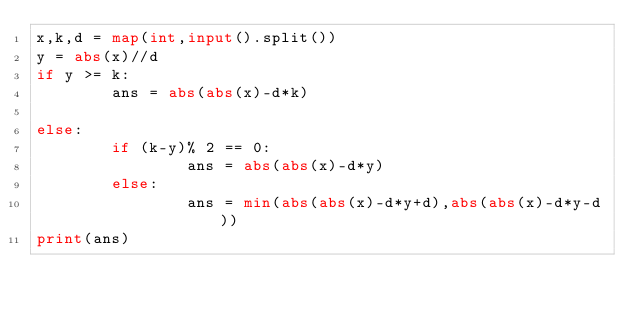Convert code to text. <code><loc_0><loc_0><loc_500><loc_500><_Python_>x,k,d = map(int,input().split())
y = abs(x)//d
if y >= k:
        ans = abs(abs(x)-d*k)

else:
        if (k-y)% 2 == 0:
                ans = abs(abs(x)-d*y)
        else:
                ans = min(abs(abs(x)-d*y+d),abs(abs(x)-d*y-d))
print(ans)</code> 